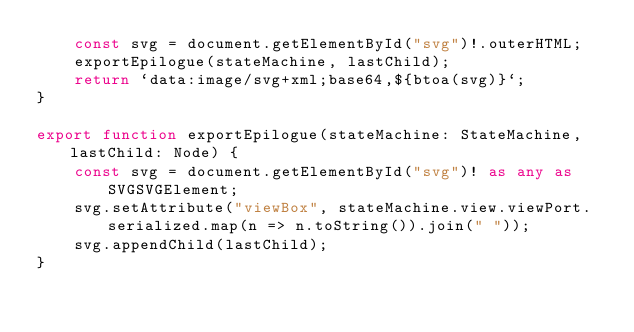<code> <loc_0><loc_0><loc_500><loc_500><_TypeScript_>    const svg = document.getElementById("svg")!.outerHTML;
    exportEpilogue(stateMachine, lastChild);
    return `data:image/svg+xml;base64,${btoa(svg)}`;
}

export function exportEpilogue(stateMachine: StateMachine, lastChild: Node) {
    const svg = document.getElementById("svg")! as any as SVGSVGElement;
    svg.setAttribute("viewBox", stateMachine.view.viewPort.serialized.map(n => n.toString()).join(" "));
    svg.appendChild(lastChild);
}
</code> 